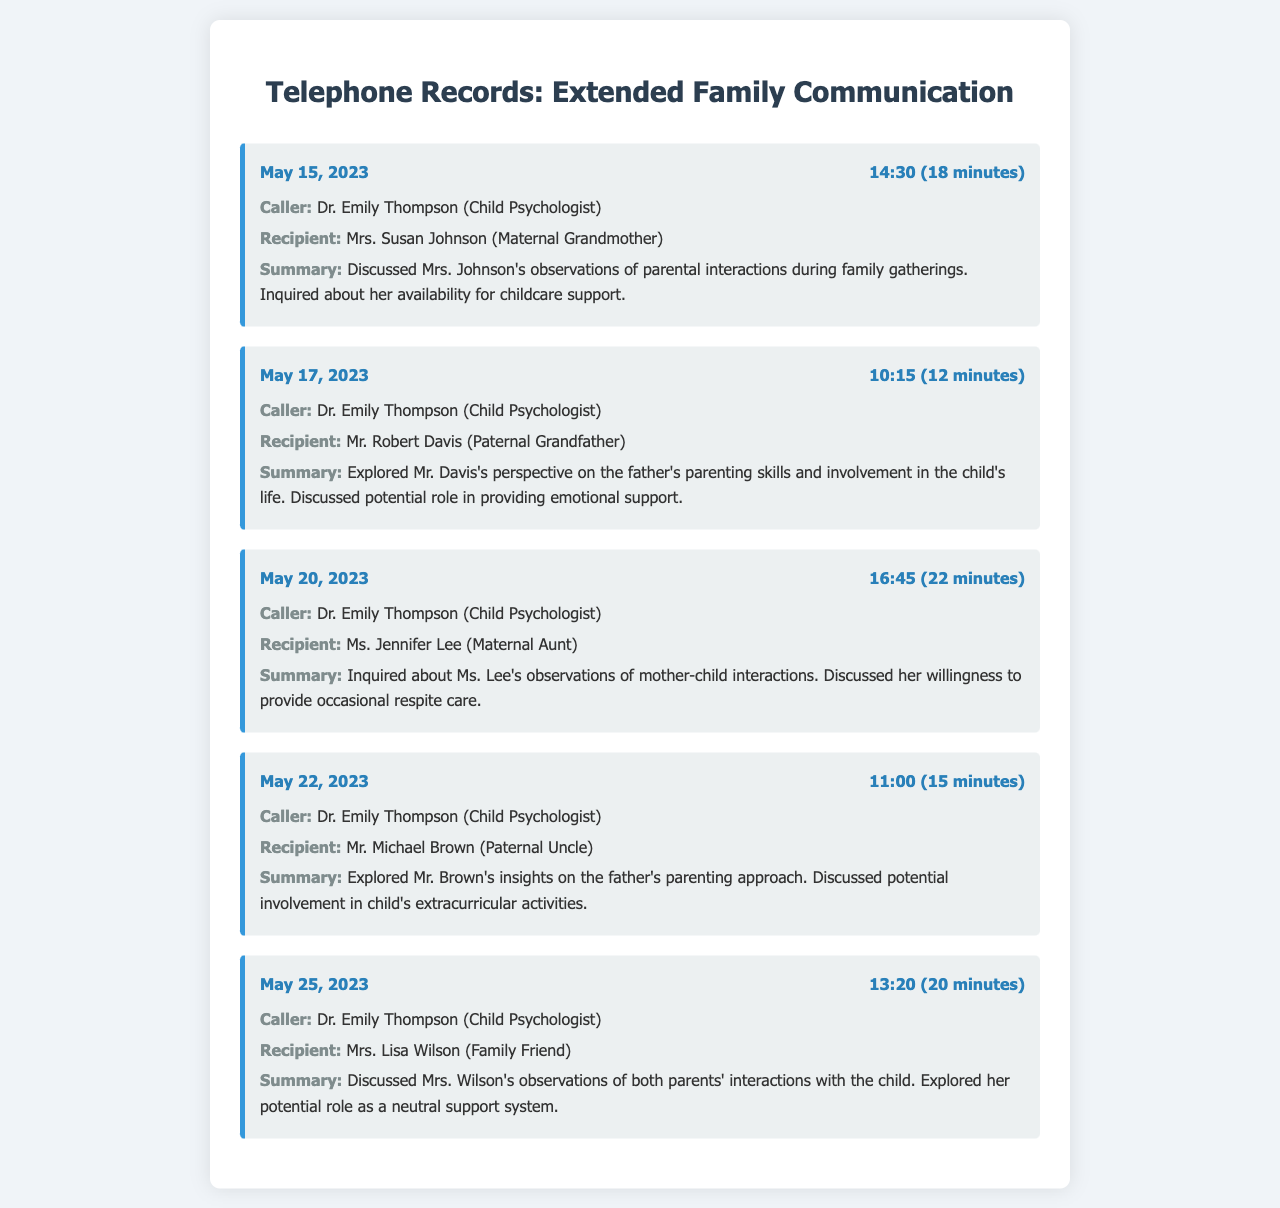What date was the call made to Mrs. Susan Johnson? The call to Mrs. Susan Johnson was recorded on May 15, 2023.
Answer: May 15, 2023 Who was the recipient of the call on May 17, 2023? The recipient of the call on May 17, 2023, was Mr. Robert Davis.
Answer: Mr. Robert Davis How long was the call to Ms. Jennifer Lee? The call to Ms. Jennifer Lee lasted for 22 minutes.
Answer: 22 minutes What was discussed during the call with Mr. Michael Brown? The call with Mr. Michael Brown focused on exploring his insights on the father's parenting approach.
Answer: Father's parenting approach Who is the caller in all records? The caller in all records is Dr. Emily Thompson.
Answer: Dr. Emily Thompson What type of support did Mrs. Lisa Wilson potentially offer? Mrs. Lisa Wilson potentially offered to be a neutral support system.
Answer: Neutral support system 